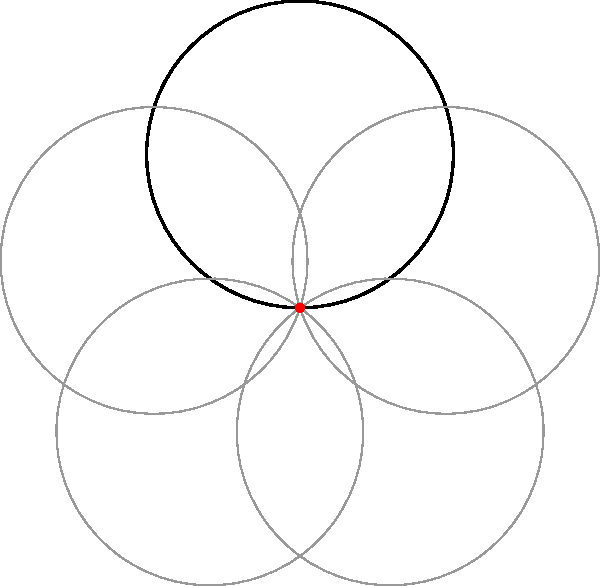In creating a kaleidoscopic effect for a complex line drawing, you rotate the original shape around a central point. If the original shape is rotated 5 times (including its original position) to create a complete circular pattern, what is the angle of rotation between each iteration of the shape? To determine the angle of rotation between each iteration:

1. A complete circular pattern covers 360°.
2. The shape is rotated 5 times to complete the pattern (including its original position).
3. To find the angle between each rotation, divide the total degrees by the number of rotations:

   $$\text{Angle of rotation} = \frac{\text{Total degrees}}{\text{Number of rotations}}$$
   
   $$\text{Angle of rotation} = \frac{360°}{5} = 72°$$

4. This means that each subsequent iteration of the shape is rotated 72° from the previous one.

5. You can verify this by multiplying the angle by the number of rotations minus one:
   
   $$72° \times (5-1) = 72° \times 4 = 288°$$

   The last rotation brings the shape back to its starting position, completing the 360° circle.
Answer: 72° 